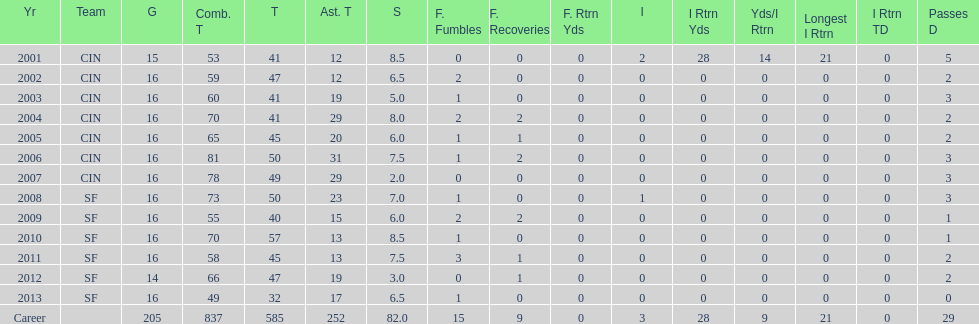I'm looking to parse the entire table for insights. Could you assist me with that? {'header': ['Yr', 'Team', 'G', 'Comb. T', 'T', 'Ast. T', 'S', 'F. Fumbles', 'F. Recoveries', 'F. Rtrn Yds', 'I', 'I Rtrn Yds', 'Yds/I Rtrn', 'Longest I Rtrn', 'I Rtrn TD', 'Passes D'], 'rows': [['2001', 'CIN', '15', '53', '41', '12', '8.5', '0', '0', '0', '2', '28', '14', '21', '0', '5'], ['2002', 'CIN', '16', '59', '47', '12', '6.5', '2', '0', '0', '0', '0', '0', '0', '0', '2'], ['2003', 'CIN', '16', '60', '41', '19', '5.0', '1', '0', '0', '0', '0', '0', '0', '0', '3'], ['2004', 'CIN', '16', '70', '41', '29', '8.0', '2', '2', '0', '0', '0', '0', '0', '0', '2'], ['2005', 'CIN', '16', '65', '45', '20', '6.0', '1', '1', '0', '0', '0', '0', '0', '0', '2'], ['2006', 'CIN', '16', '81', '50', '31', '7.5', '1', '2', '0', '0', '0', '0', '0', '0', '3'], ['2007', 'CIN', '16', '78', '49', '29', '2.0', '0', '0', '0', '0', '0', '0', '0', '0', '3'], ['2008', 'SF', '16', '73', '50', '23', '7.0', '1', '0', '0', '1', '0', '0', '0', '0', '3'], ['2009', 'SF', '16', '55', '40', '15', '6.0', '2', '2', '0', '0', '0', '0', '0', '0', '1'], ['2010', 'SF', '16', '70', '57', '13', '8.5', '1', '0', '0', '0', '0', '0', '0', '0', '1'], ['2011', 'SF', '16', '58', '45', '13', '7.5', '3', '1', '0', '0', '0', '0', '0', '0', '2'], ['2012', 'SF', '14', '66', '47', '19', '3.0', '0', '1', '0', '0', '0', '0', '0', '0', '2'], ['2013', 'SF', '16', '49', '32', '17', '6.5', '1', '0', '0', '0', '0', '0', '0', '0', '0'], ['Career', '', '205', '837', '585', '252', '82.0', '15', '9', '0', '3', '28', '9', '21', '0', '29']]} What is the only season he has fewer than three sacks? 2007. 